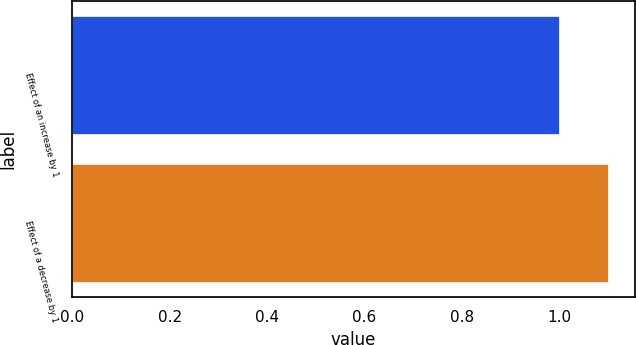Convert chart to OTSL. <chart><loc_0><loc_0><loc_500><loc_500><bar_chart><fcel>Effect of an increase by 1<fcel>Effect of a decrease by 1<nl><fcel>1<fcel>1.1<nl></chart> 